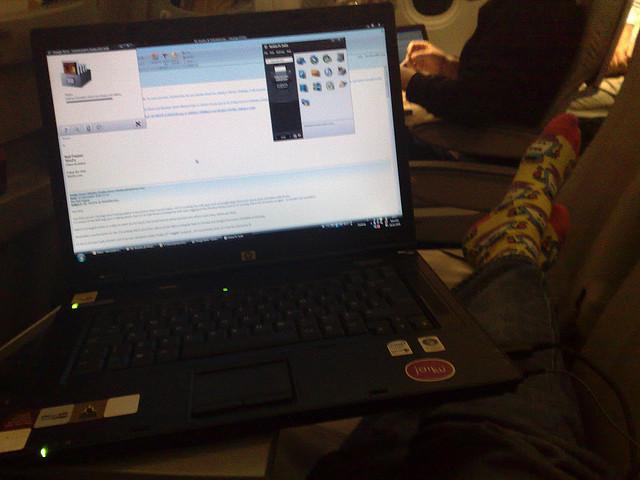What color is the laptop?
Answer briefly. Black. What is this laptop resting on?
Write a very short answer. Desk. What is on the laptop?
Short answer required. Stickers. Where is the laptop?
Keep it brief. Airplane. What color is the sock?
Short answer required. Yellow. What is shown on the monitor?
Concise answer only. Website. What part of the computer is the girl currently touching?
Quick response, please. Keyboard. What type of computer is it?
Quick response, please. Laptop. What is Mark Wahlberg discussing online?
Be succinct. Business. What website is being used?
Short answer required. Outlook. What is the laptop sitting on?
Keep it brief. Desk. What are the two words on the blue strip?
Concise answer only. Windows 10. Are there stickers on the computer?
Quick response, please. Yes. Where are the laptops?
Write a very short answer. Lap. Does the desk light up?
Quick response, please. No. What is the brand of the device?
Answer briefly. Dell. Is this a desktop computer?
Concise answer only. No. How many speakers does the electronic device have?
Concise answer only. 2. What webpage is on the computer?
Quick response, please. Email. 